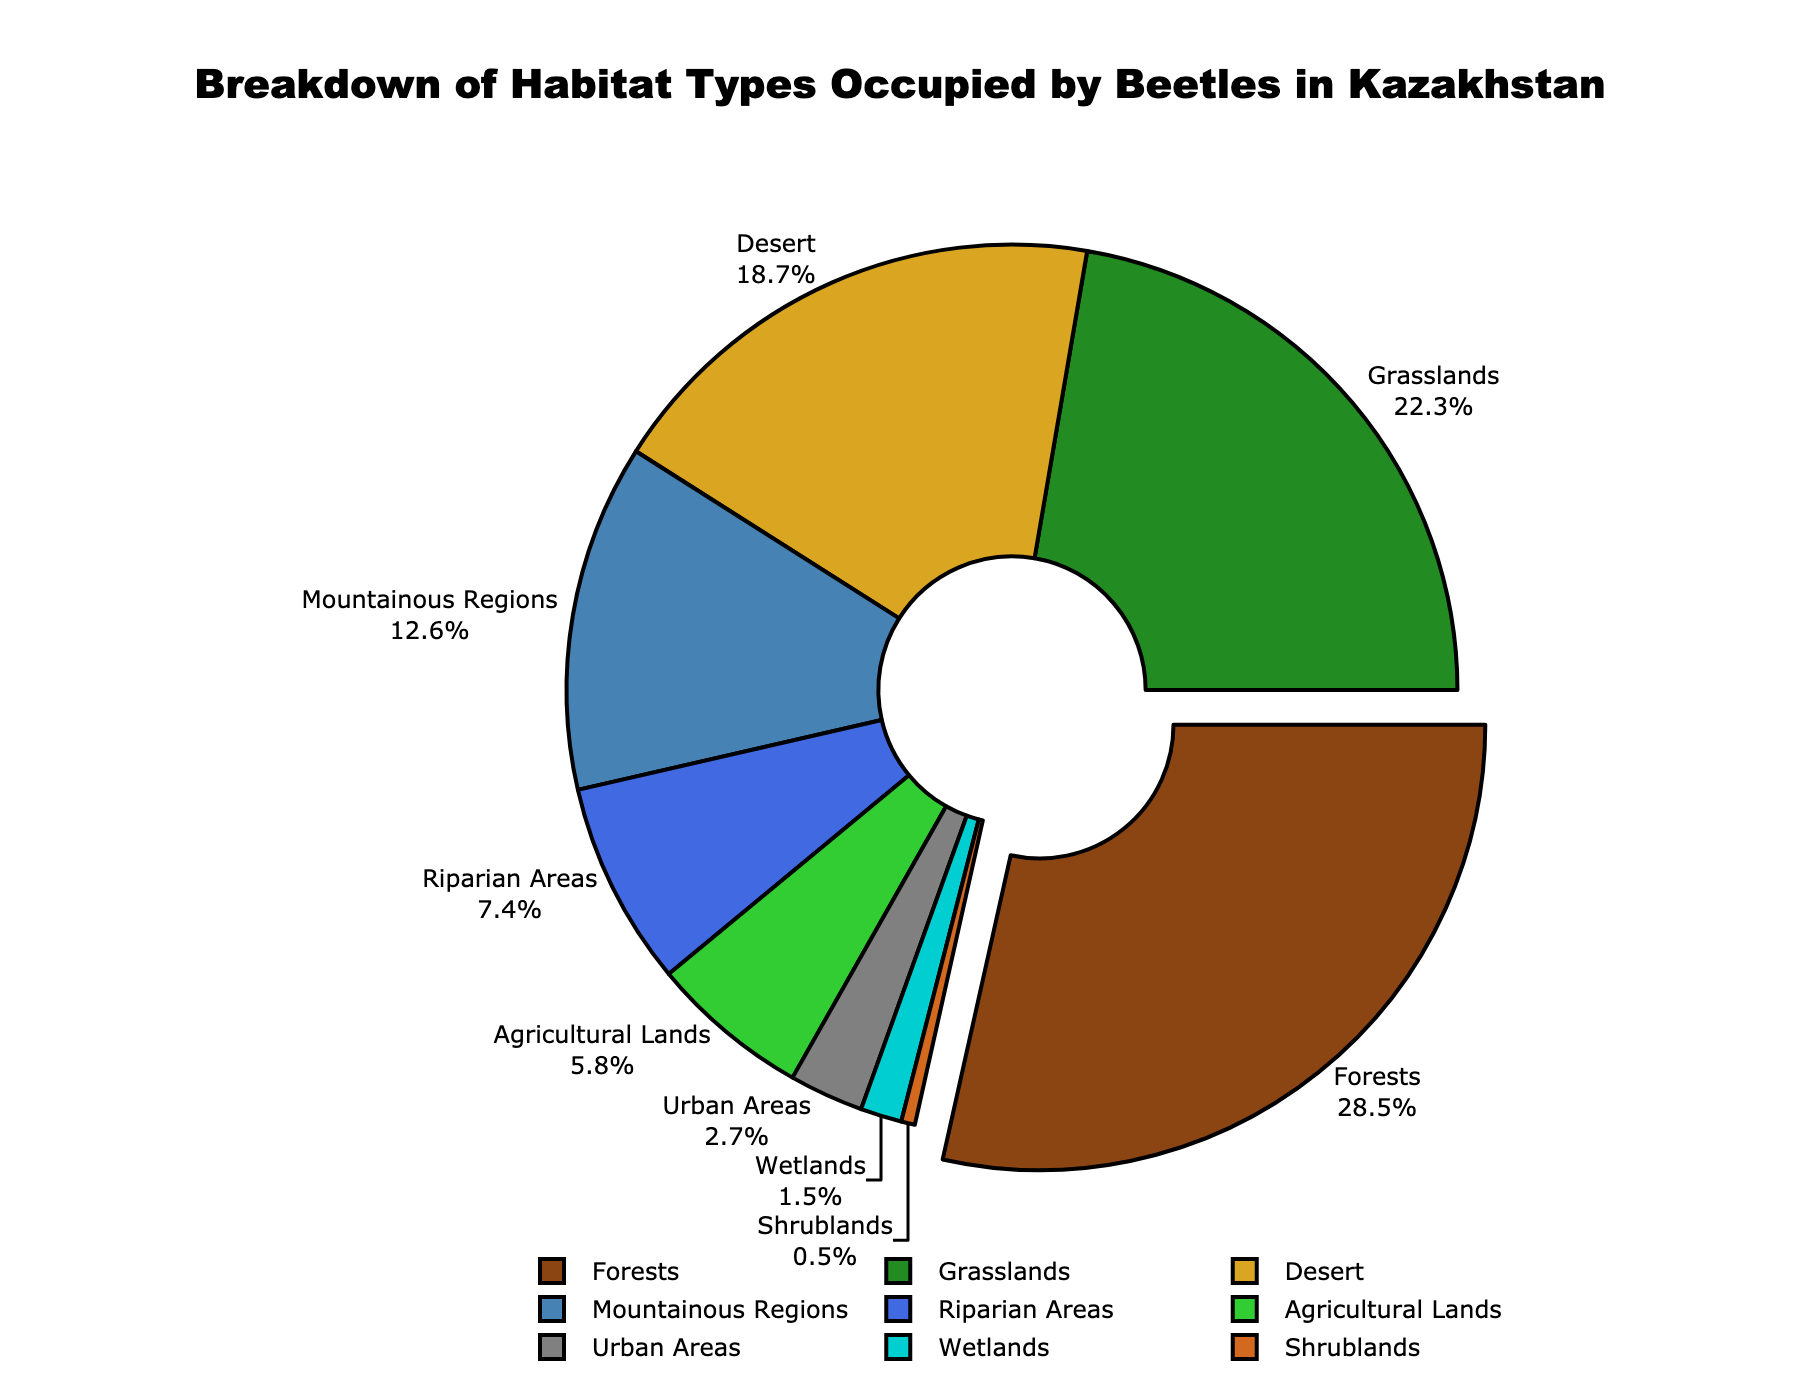Which habitat type occupies the largest area for beetles in Kazakhstan? The largest area is represented by the segment pulled out from the center. According to the chart, "Forests" occupies the largest area.
Answer: Forests Which habitat type has the smallest percentage of beetle occupancy? The smallest area within the pie chart represents the habitat type with the lowest percentage. According to the chart, "Shrublands" occupy the smallest percentage.
Answer: Shrublands What is the combined percentage of beetles found in Forests and Grasslands? Sum the percentages of Forests (28.5%) and Grasslands (22.3%). The combined percentage is 28.5 + 22.3 = 50.8%.
Answer: 50.8% Is the percentage of beetles in Agricultural Lands greater than Urban Areas? Compare the percentage of Agricultural Lands (5.8%) with Urban Areas (2.7%). Since 5.8 > 2.7, the percentage is greater.
Answer: Yes What is the difference in percentage of beetle occupancy between Desert and Mountainous Regions? Subtract the percentage of Mountainous Regions (12.6%) from Desert (18.7%). The difference is 18.7 - 12.6 = 6.1%.
Answer: 6.1% Which habitats have less than 5% of beetle occupancy? Identify habitat types with percentages less than 5%. Riparian Areas (7.4%), Agricultural Lands (5.8%), Urban Areas (2.7%), and Wetlands (1.5%) fit this criterion.
Answer: Wetlands, Shrublands, and Urban Areas Which two habitat types have a combined percentage close to the percentage of Desert occupancy? The percentage of Desert is 18.7%. Two habitat types whose percentages add up to around 18.7% are Riparian Areas (7.4%) and Agricultural Lands (5.8%). The sum is 7.4 + 5.8 + 2.7 = 15.9%, close to the target.
Answer: Riparian Areas and Agricultural Lands What is the median percentage value of the habitat types? List all percentages: 28.5, 22.3, 18.7, 12.6, 7.4, 5.8, 2.7, 1.5, 0.5. Arrange them in ascending order: 0.5, 1.5, 2.7, 5.8, 7.4, 12.6, 18.7, 22.3, 28.5. The middle value (5th in the ordered list) is 7.4%.
Answer: 7.4% What color represents the beetles in Desert habitats on the pie chart? Identify the color assigned to the "Desert" label by observing the pie chart. The Desert habitat is represented by a gold/yellow slice.
Answer: Gold/Yellow How much greater is the beetle occupancy in Forests compared to Wetlands? Subtract the Wetlands percentage (1.5%) from the Forests percentage (28.5%). The difference is 28.5 - 1.5 = 27%.
Answer: 27% 